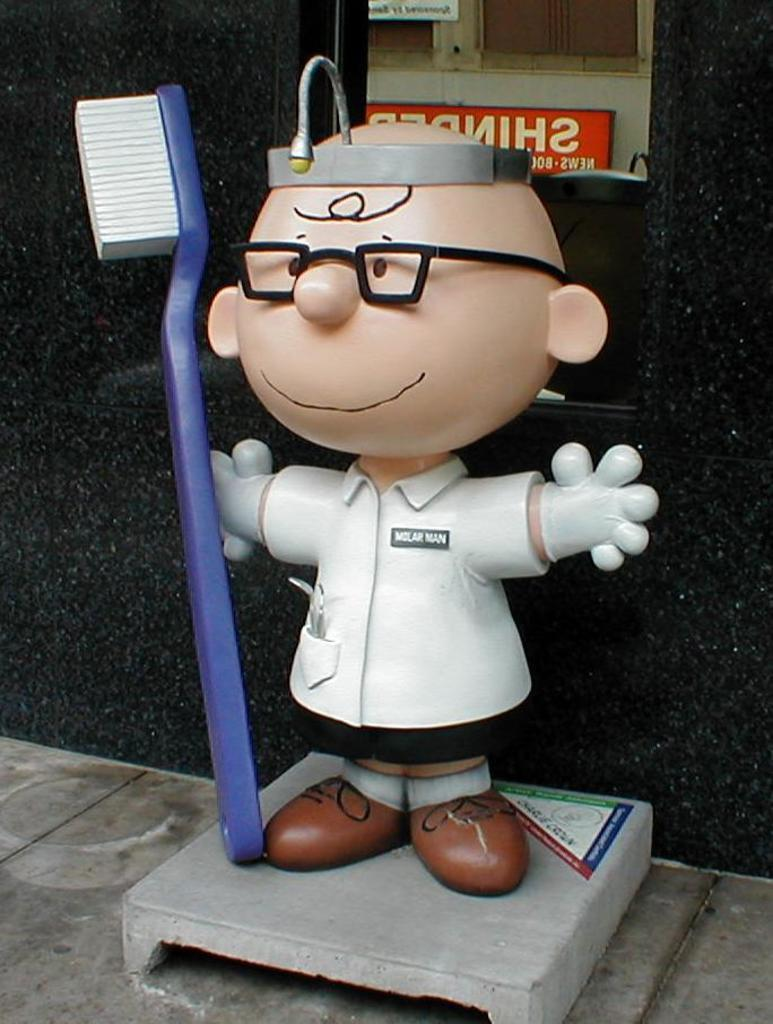Who or what is present in the image? There is a person in the image. What object can be seen on a grey surface in the image? There is a brush on a grey surface in the image. What can be seen in the background of the image? There is a wall and a board in the background of the image. What type of bait is being used by the person in the image? There is no bait present in the image; it features a person with a brush on a grey surface and a wall and board in the background. 